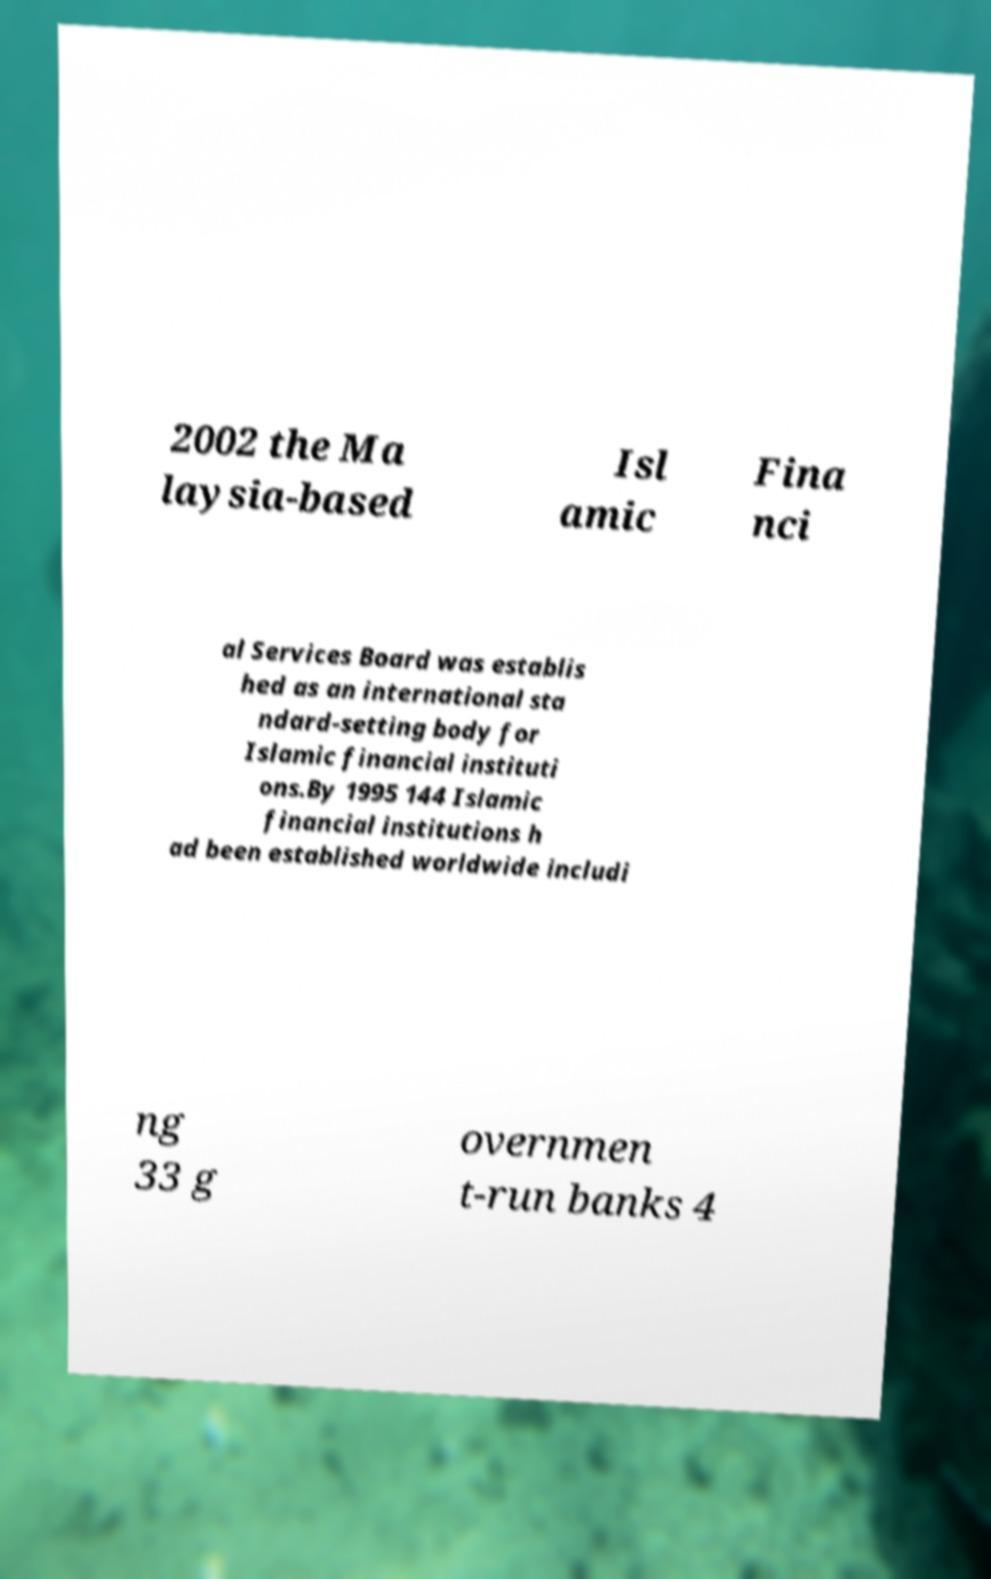What messages or text are displayed in this image? I need them in a readable, typed format. 2002 the Ma laysia-based Isl amic Fina nci al Services Board was establis hed as an international sta ndard-setting body for Islamic financial instituti ons.By 1995 144 Islamic financial institutions h ad been established worldwide includi ng 33 g overnmen t-run banks 4 